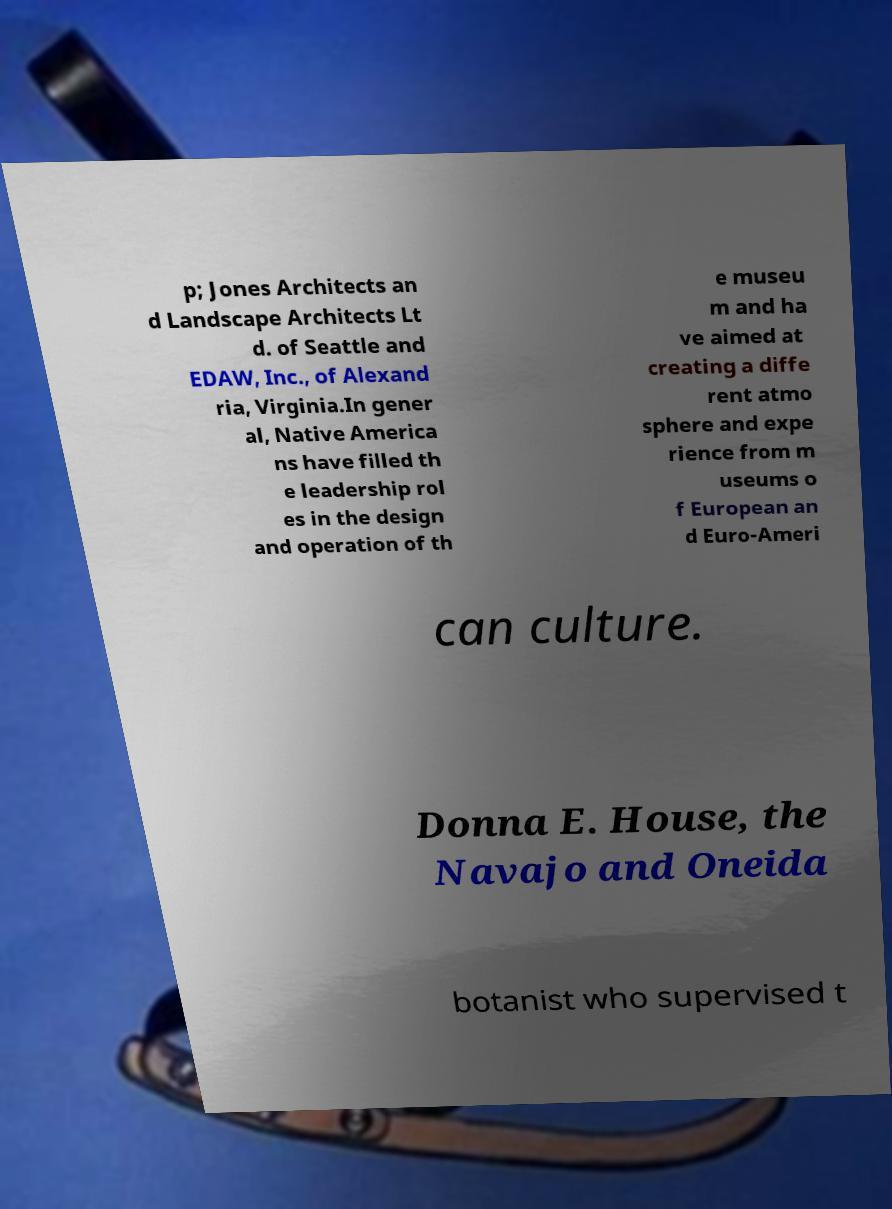Could you assist in decoding the text presented in this image and type it out clearly? p; Jones Architects an d Landscape Architects Lt d. of Seattle and EDAW, Inc., of Alexand ria, Virginia.In gener al, Native America ns have filled th e leadership rol es in the design and operation of th e museu m and ha ve aimed at creating a diffe rent atmo sphere and expe rience from m useums o f European an d Euro-Ameri can culture. Donna E. House, the Navajo and Oneida botanist who supervised t 